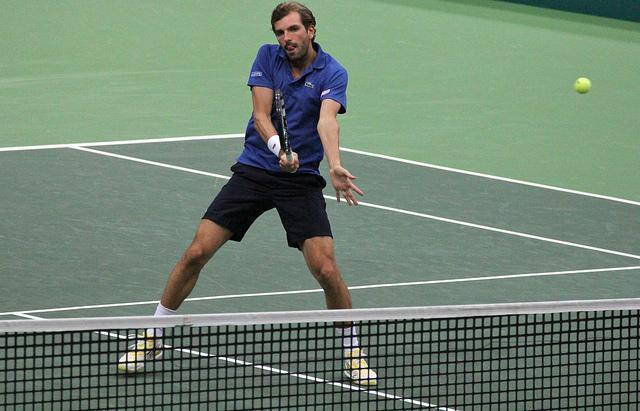How many zebras are in the scene?
Give a very brief answer. 0. 